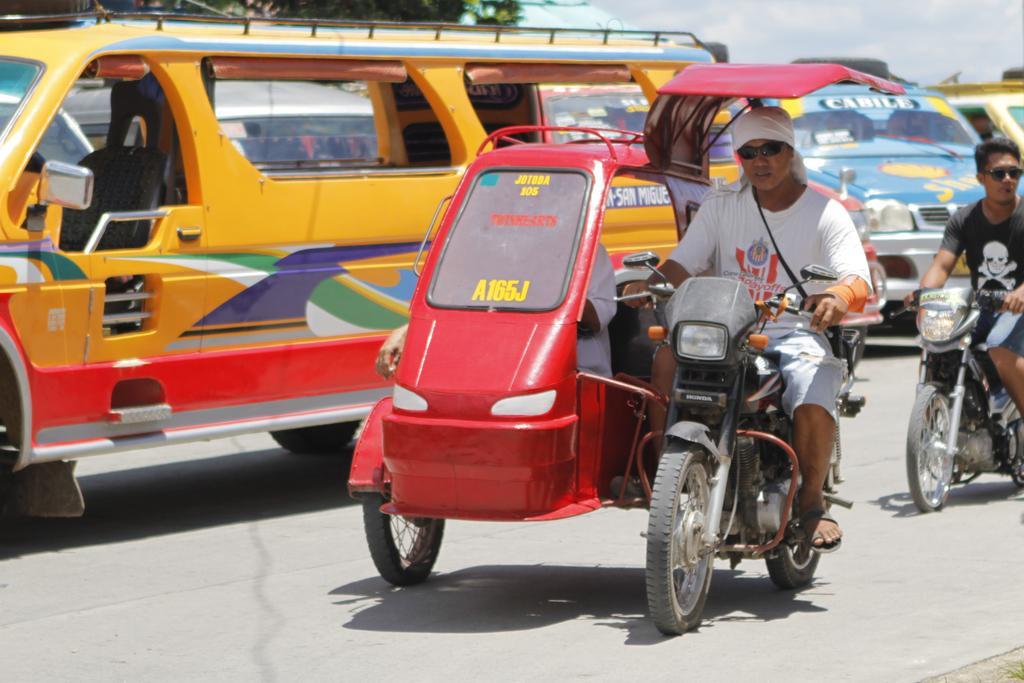How would you summarize this image in a sentence or two? There are group of vehicles on the road. One truck is in yellow in color. One vehicle is in red in color and two men were riding on it. One person is wearing a white shirt and he is wearing a goggles. On the other vehicle, there is a man,he is wearing a black shirt and also wearing a goggles. In the background there is a tree and a cloudy sky. 